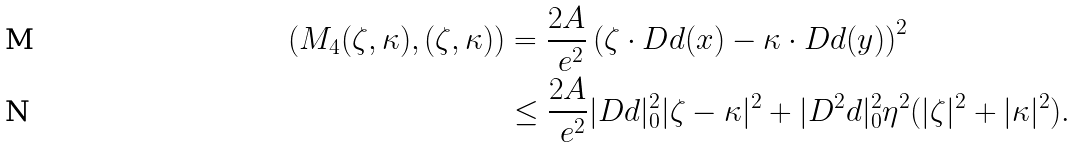<formula> <loc_0><loc_0><loc_500><loc_500>( M _ { 4 } ( \zeta , \kappa ) , ( \zeta , \kappa ) ) & = \frac { 2 A } { \ e ^ { 2 } } \left ( \zeta \cdot D d ( x ) - \kappa \cdot D d ( y ) \right ) ^ { 2 } \\ & \leq \frac { 2 A } { \ e ^ { 2 } } | D d | _ { 0 } ^ { 2 } | \zeta - \kappa | ^ { 2 } + | D ^ { 2 } d | _ { 0 } ^ { 2 } \eta ^ { 2 } ( | \zeta | ^ { 2 } + | \kappa | ^ { 2 } ) .</formula> 